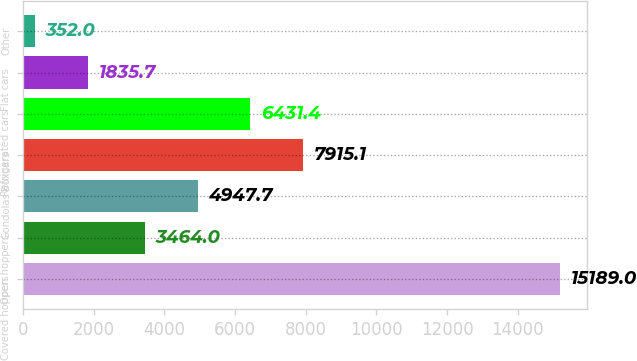Convert chart to OTSL. <chart><loc_0><loc_0><loc_500><loc_500><bar_chart><fcel>Covered hoppers<fcel>Open hoppers<fcel>Gondolas<fcel>Boxcars<fcel>Refrigerated cars<fcel>Flat cars<fcel>Other<nl><fcel>15189<fcel>3464<fcel>4947.7<fcel>7915.1<fcel>6431.4<fcel>1835.7<fcel>352<nl></chart> 